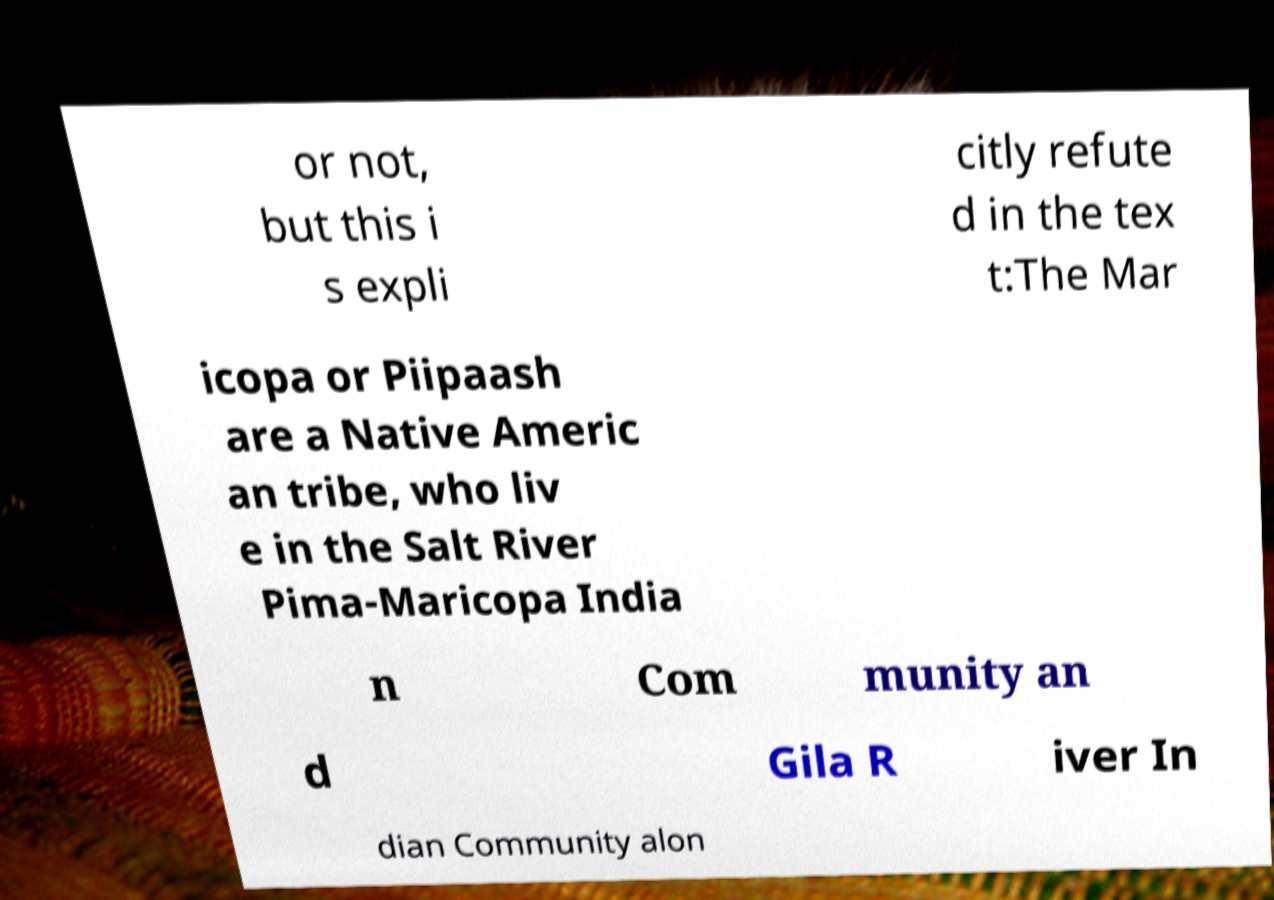Please identify and transcribe the text found in this image. or not, but this i s expli citly refute d in the tex t:The Mar icopa or Piipaash are a Native Americ an tribe, who liv e in the Salt River Pima-Maricopa India n Com munity an d Gila R iver In dian Community alon 